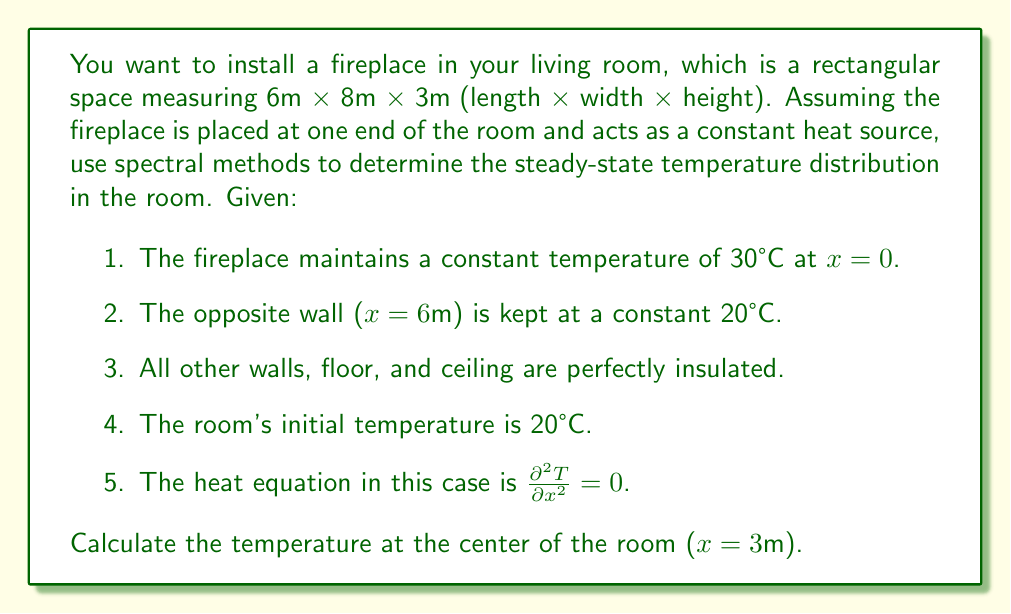Can you solve this math problem? To solve this problem using spectral methods, we'll follow these steps:

1) The general solution to the steady-state heat equation $\frac{\partial^2 T}{\partial x^2} = 0$ is:

   $T(x) = Ax + B$

2) Apply the boundary conditions:
   At x = 0, T = 30°C
   At x = 6m, T = 20°C

3) Substituting these into our general solution:
   30 = B
   20 = 6A + B

4) Solving these equations:
   B = 30
   6A + 30 = 20
   6A = -10
   A = -5/3

5) Therefore, our temperature distribution function is:
   $T(x) = -\frac{5}{3}x + 30$

6) To find the temperature at the center of the room (x = 3m), we substitute x = 3 into our equation:

   $T(3) = -\frac{5}{3}(3) + 30 = -5 + 30 = 25$

Thus, the temperature at the center of the room is 25°C.
Answer: 25°C 